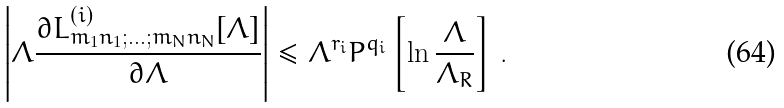<formula> <loc_0><loc_0><loc_500><loc_500>\left | \Lambda \frac { \partial L _ { m _ { 1 } n _ { 1 } ; \dots ; m _ { N } n _ { N } } ^ { ( i ) } [ \Lambda ] } { \partial \Lambda } \right | \leq \Lambda ^ { r _ { i } } P ^ { q _ { i } } \left [ \ln \frac { \Lambda } { \Lambda _ { R } } \right ] \, .</formula> 